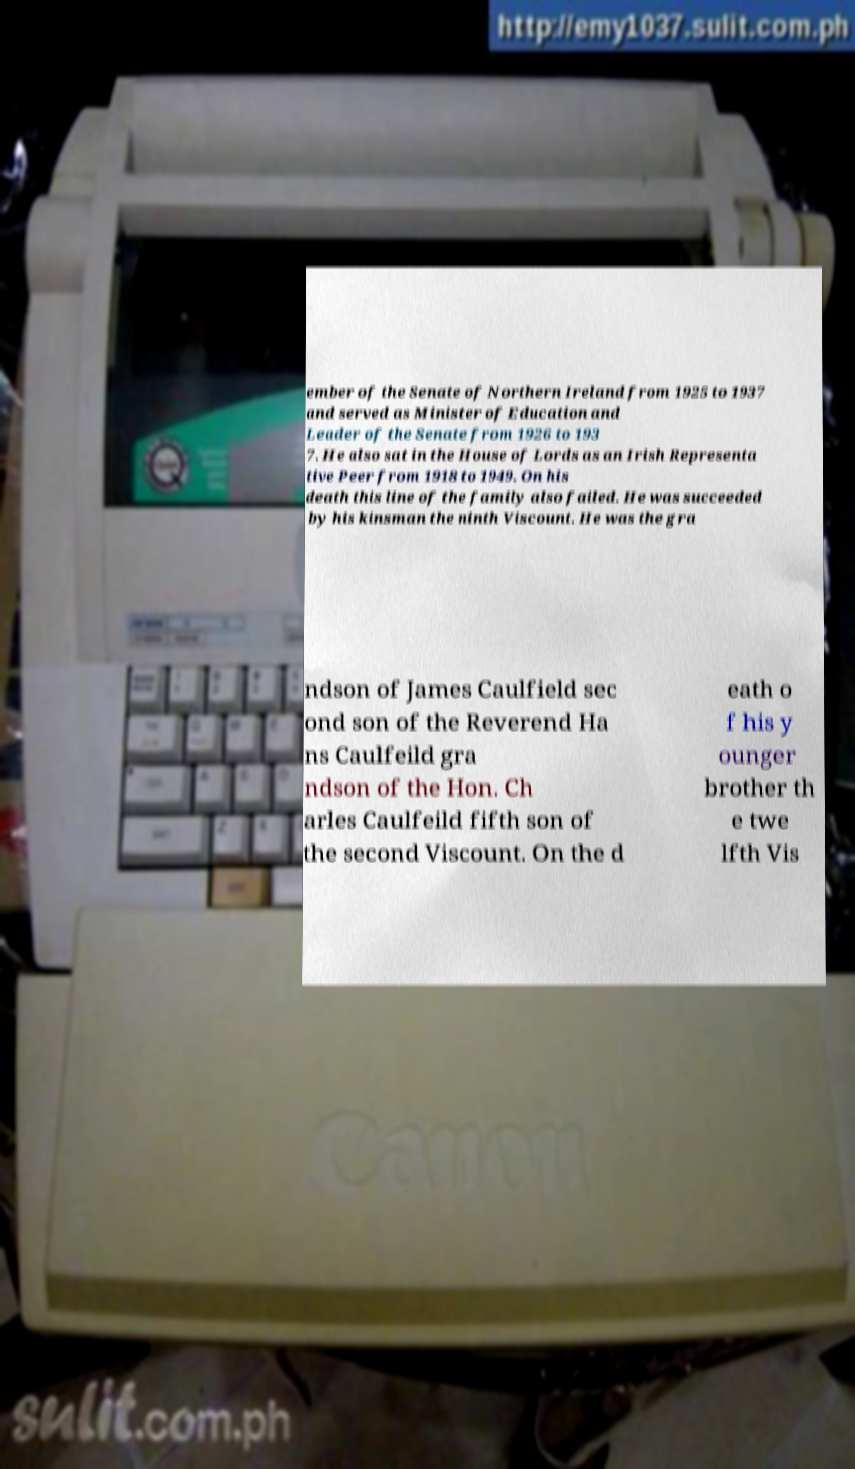Please identify and transcribe the text found in this image. ember of the Senate of Northern Ireland from 1925 to 1937 and served as Minister of Education and Leader of the Senate from 1926 to 193 7. He also sat in the House of Lords as an Irish Representa tive Peer from 1918 to 1949. On his death this line of the family also failed. He was succeeded by his kinsman the ninth Viscount. He was the gra ndson of James Caulfield sec ond son of the Reverend Ha ns Caulfeild gra ndson of the Hon. Ch arles Caulfeild fifth son of the second Viscount. On the d eath o f his y ounger brother th e twe lfth Vis 